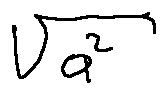<formula> <loc_0><loc_0><loc_500><loc_500>\sqrt { a ^ { 2 } }</formula> 